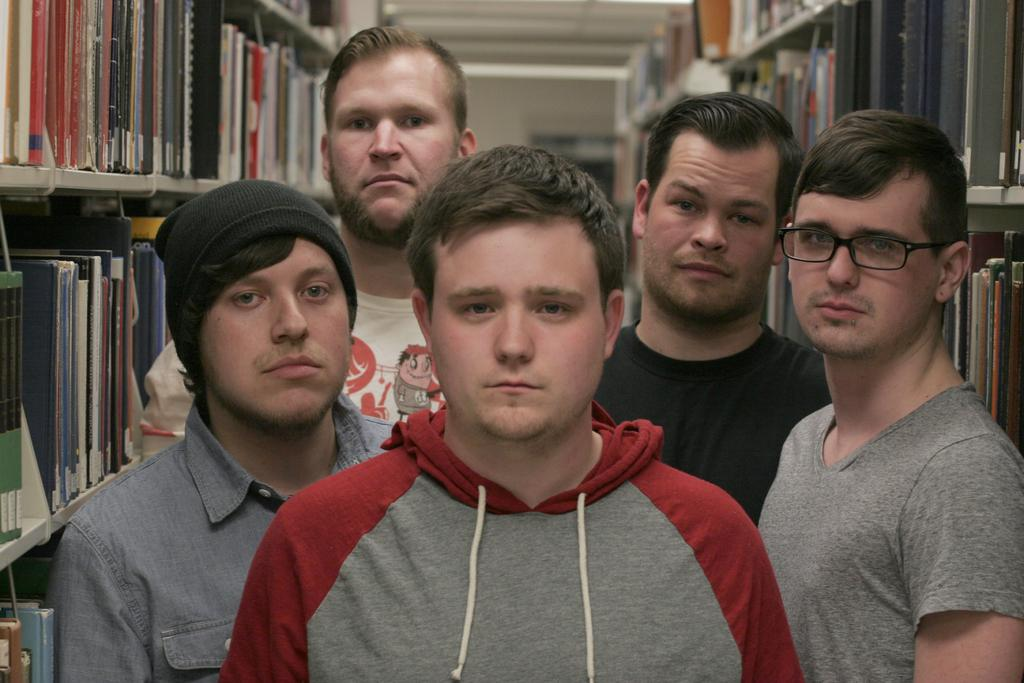Who or what is present in the image? There are people in the image. What can be seen on the shelves in the image? The shelves have objects, including books. What is the color of the wall visible in the image? The wall is not mentioned as having a specific color in the provided facts. Can you describe the white-colored object in the image? The white-colored object is not described in the provided facts. Is there any coal visible in the image? No, there is no mention of coal in the provided facts, so it cannot be determined if coal is present in the image. 